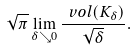Convert formula to latex. <formula><loc_0><loc_0><loc_500><loc_500>\sqrt { \pi } \lim _ { \delta \searrow 0 } \frac { \ v o l ( K _ { \delta } ) } { \sqrt { \delta } } .</formula> 